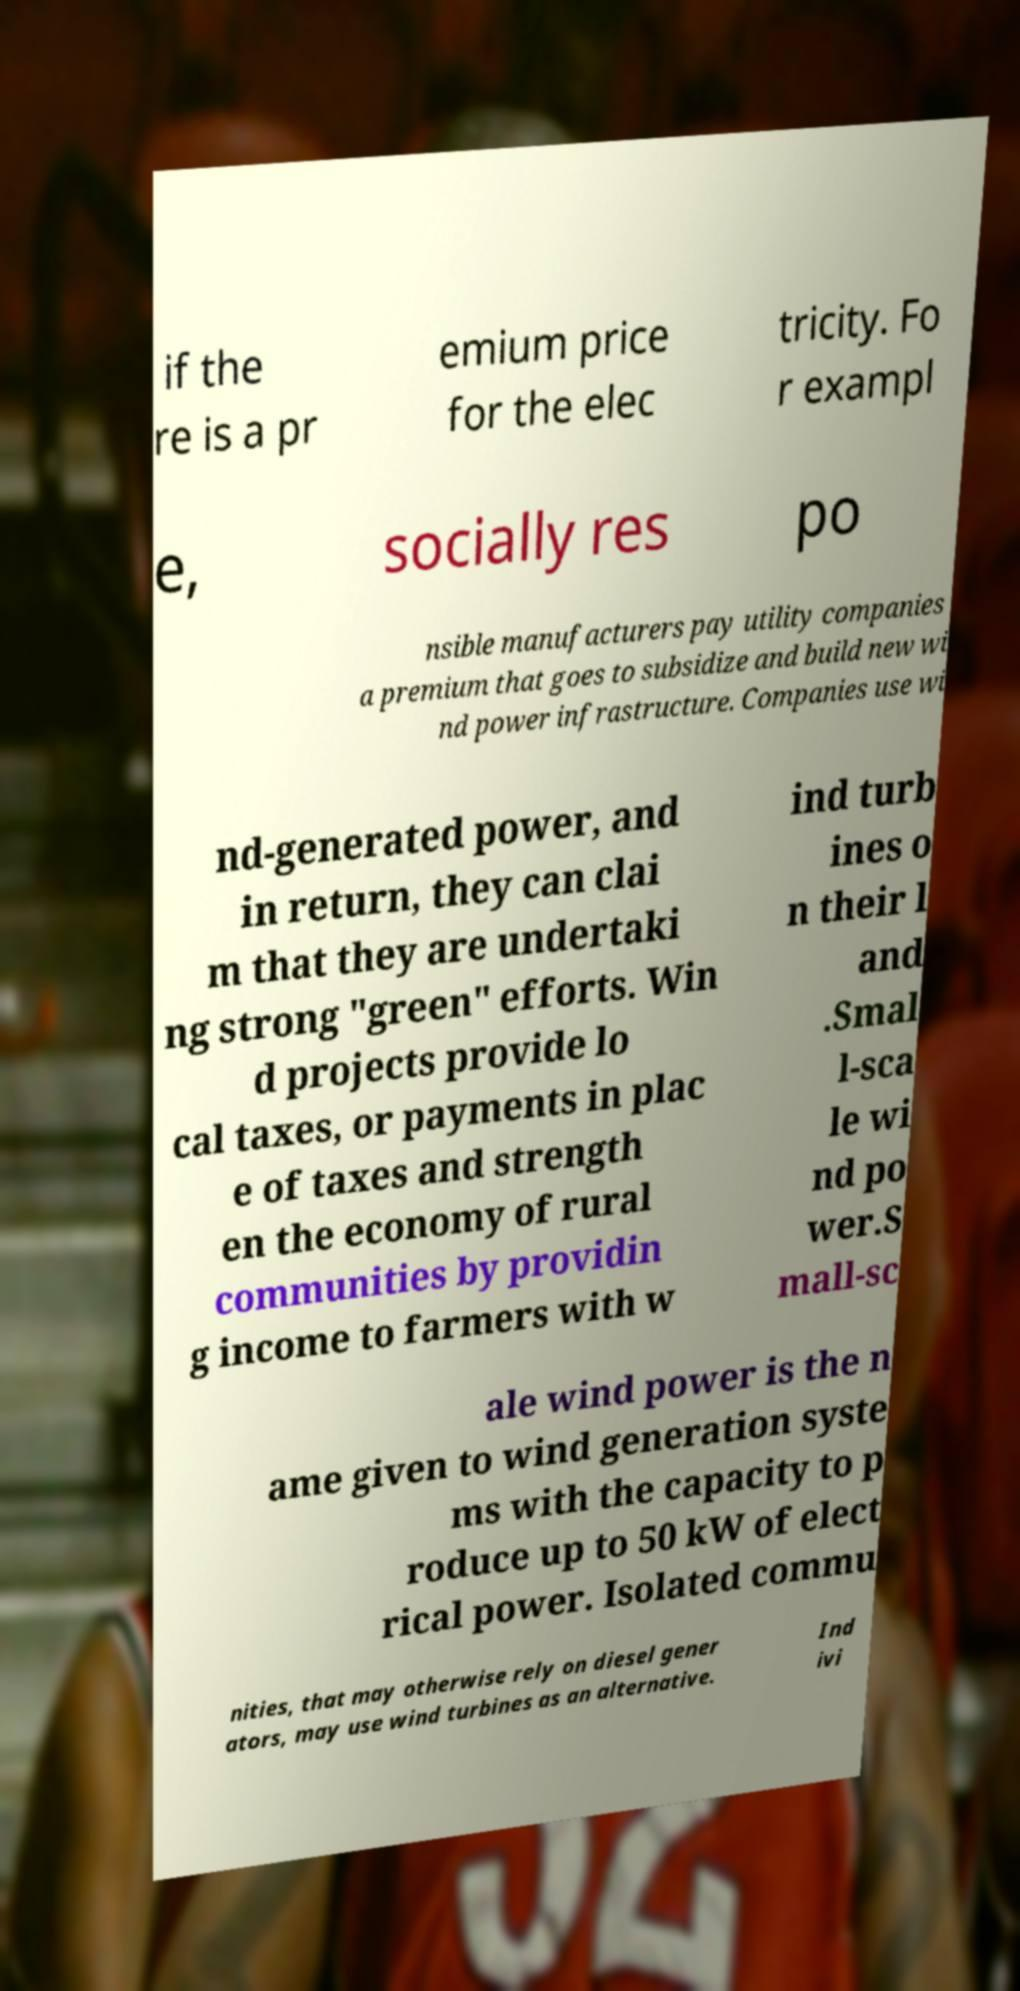Please read and relay the text visible in this image. What does it say? if the re is a pr emium price for the elec tricity. Fo r exampl e, socially res po nsible manufacturers pay utility companies a premium that goes to subsidize and build new wi nd power infrastructure. Companies use wi nd-generated power, and in return, they can clai m that they are undertaki ng strong "green" efforts. Win d projects provide lo cal taxes, or payments in plac e of taxes and strength en the economy of rural communities by providin g income to farmers with w ind turb ines o n their l and .Smal l-sca le wi nd po wer.S mall-sc ale wind power is the n ame given to wind generation syste ms with the capacity to p roduce up to 50 kW of elect rical power. Isolated commu nities, that may otherwise rely on diesel gener ators, may use wind turbines as an alternative. Ind ivi 